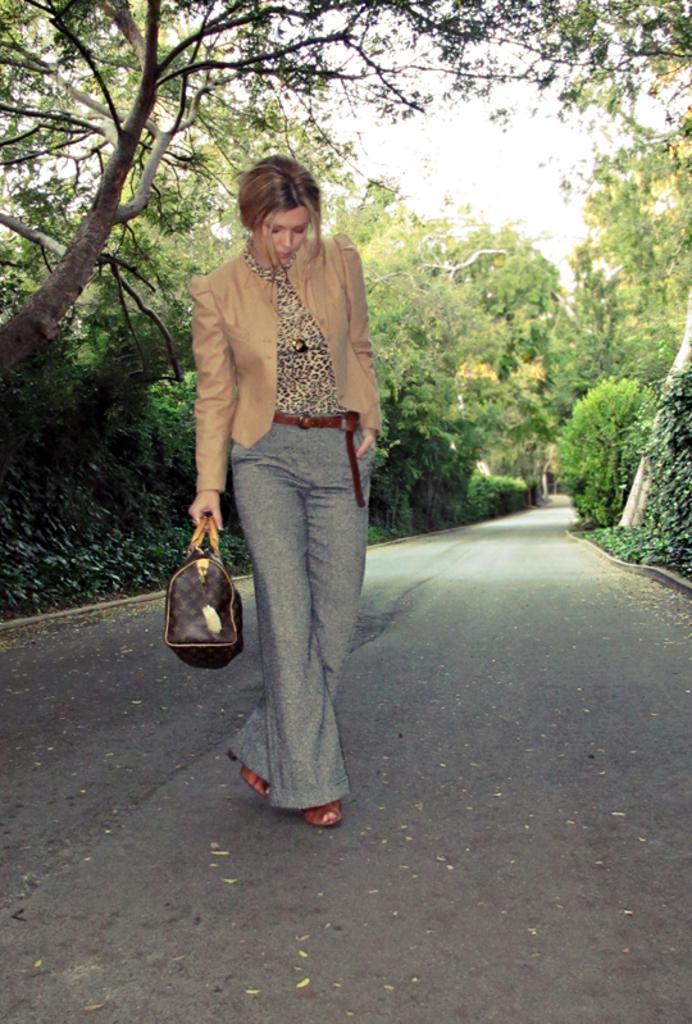Could you give a brief overview of what you see in this image? In these image there is one woman standing and she is holding a hand bag, and on the background there are some trees and sky and there is one road. 